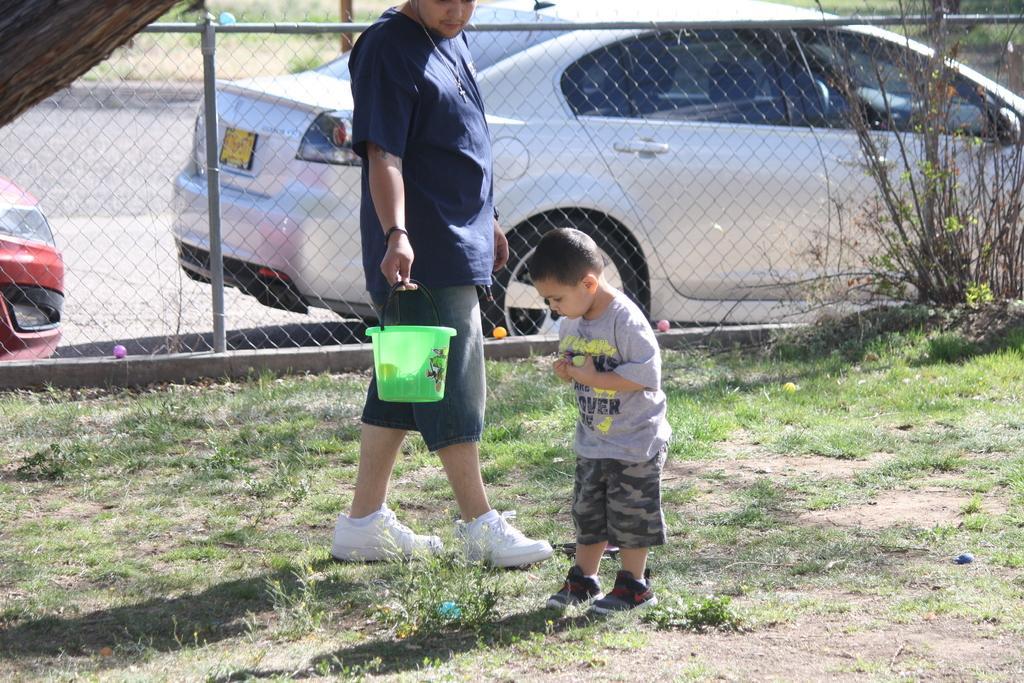Can you describe this image briefly? In this picture there is a man and a small boy in the center of the image and there is grassland at the bottom side of the image and there are cars in the background area of the image, there is a net boundary in the center of the image. 